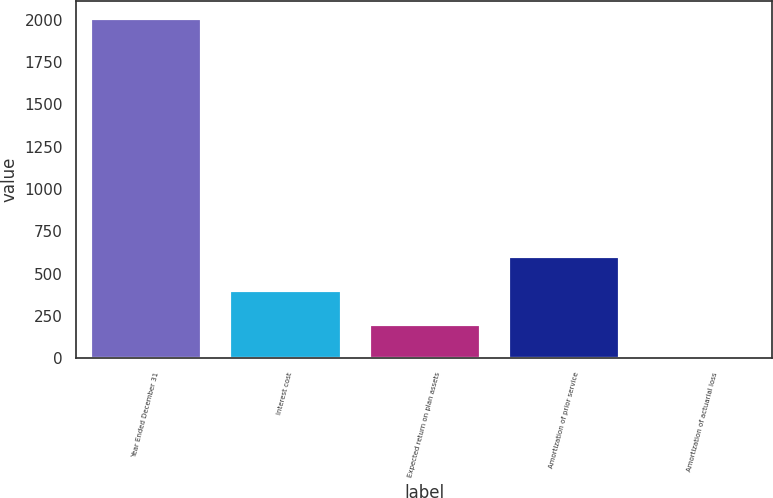Convert chart to OTSL. <chart><loc_0><loc_0><loc_500><loc_500><bar_chart><fcel>Year Ended December 31<fcel>Interest cost<fcel>Expected return on plan assets<fcel>Amortization of prior service<fcel>Amortization of actuarial loss<nl><fcel>2011<fcel>403.8<fcel>202.9<fcel>604.7<fcel>2<nl></chart> 